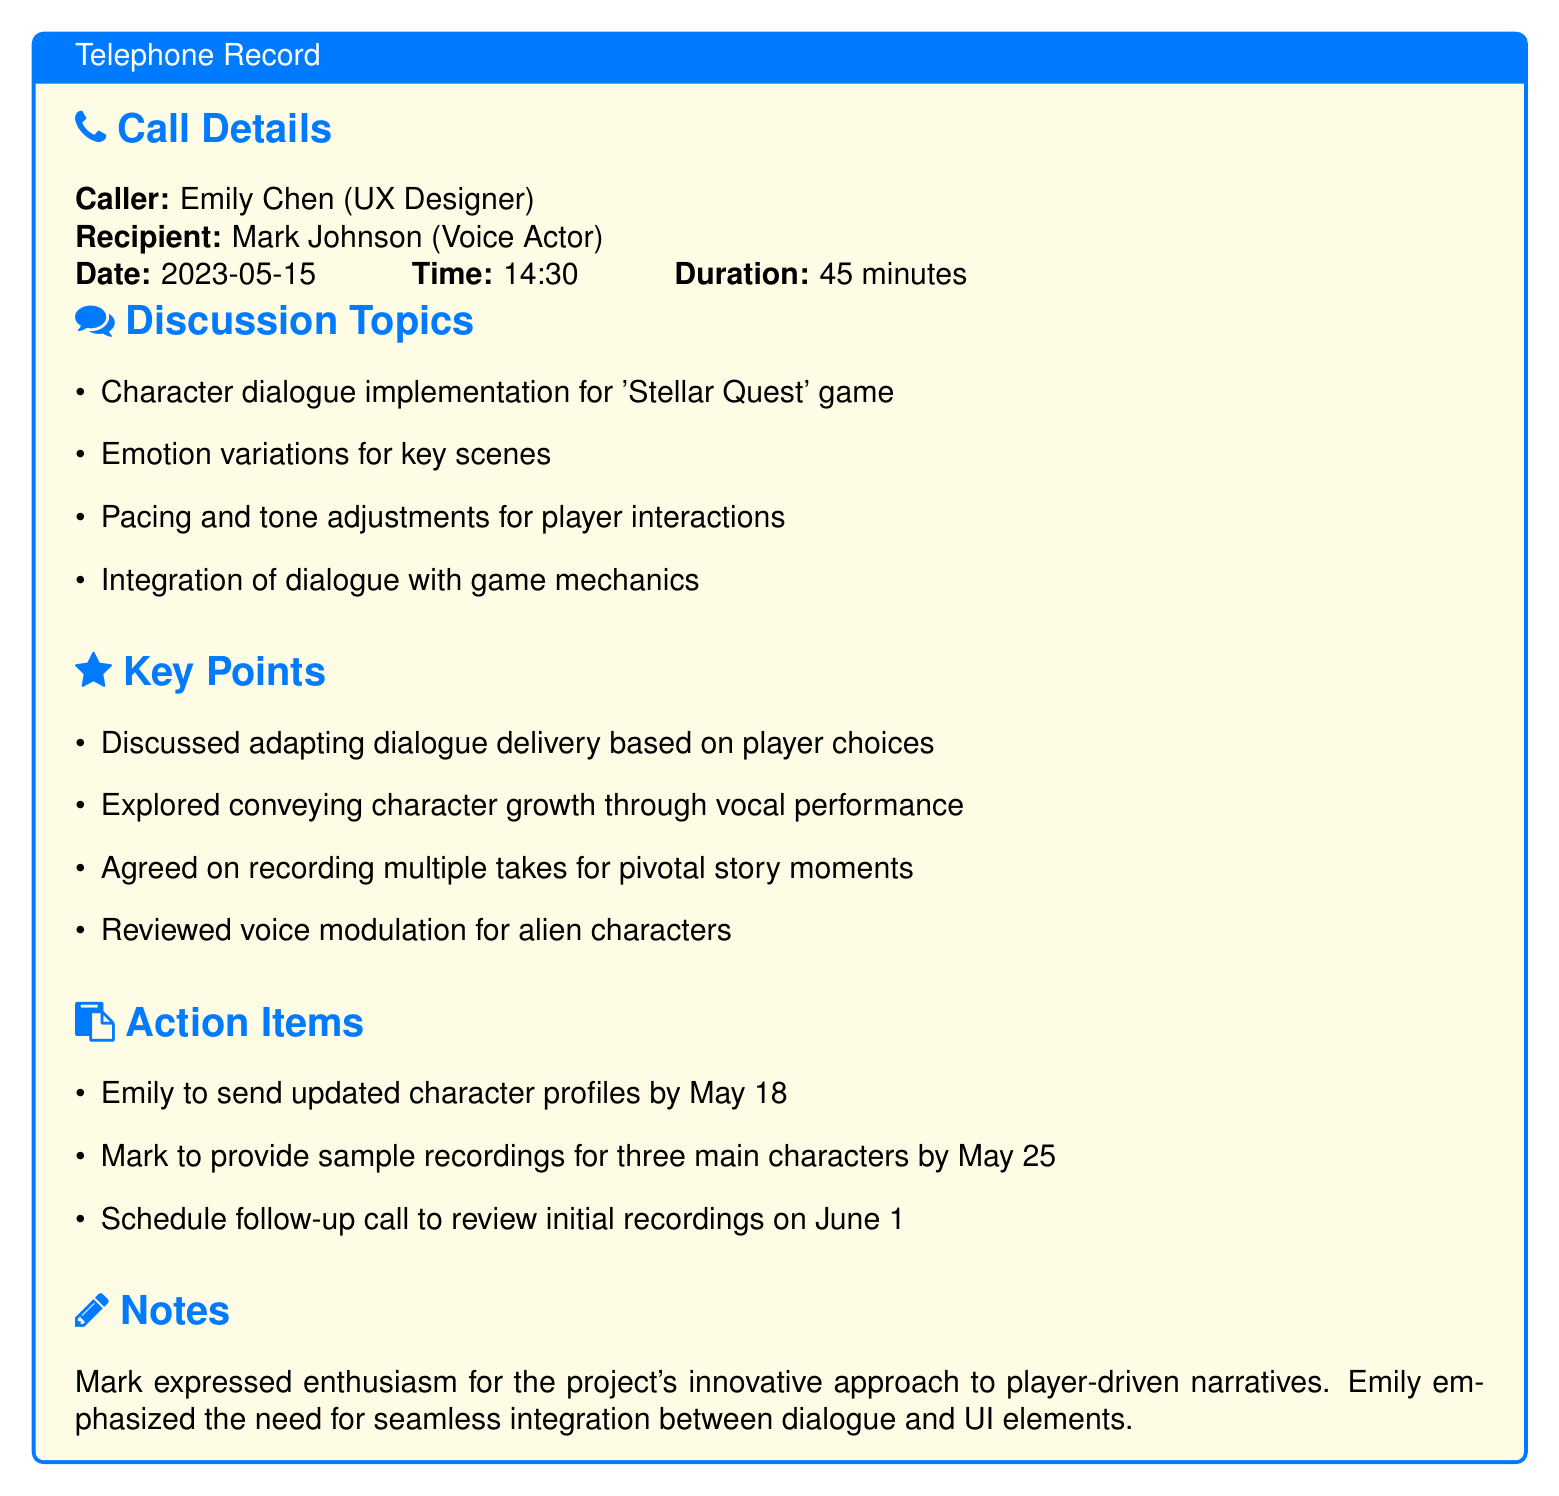What is the name of the caller? The caller's name is mentioned in the call details section of the document.
Answer: Emily Chen Who is the recipient of the call? The recipient's name is provided in the call details section of the document.
Answer: Mark Johnson What was the date of the call? The date of the call is specified in the call details section.
Answer: 2023-05-15 How long was the conversation? The duration of the call is mentioned in the call details section.
Answer: 45 minutes What is a key discussion topic? Key discussion topics are listed under the discussion topics section in the document.
Answer: Character dialogue implementation for 'Stellar Quest' game What is one action item for Emily? Action items are detailed in the document, specifically for each person.
Answer: Send updated character profiles by May 18 How many main characters' sample recordings is Mark to provide? This detail is found in the action items, which lists Mark's responsibilities.
Answer: Three When is the follow-up call scheduled? The date of the follow-up call is mentioned in the action items section of the document.
Answer: June 1 What did Mark express during the call? This is noted in the notes section of the document.
Answer: Enthusiasm for the project's innovative approach What did Emily emphasize regarding dialogue? This detail is indicated in the notes section concerning the integration of elements.
Answer: Seamless integration between dialogue and UI elements 